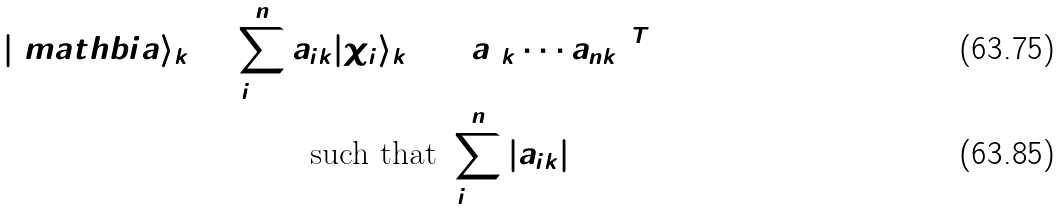<formula> <loc_0><loc_0><loc_500><loc_500>| \ m a t h b i { a } \rangle _ { k } = \sum _ { i = 1 } ^ { n } a _ { i k } | \chi _ { i } \rangle _ { k } = \left ( a _ { 1 k } \cdots a _ { n k } \right ) ^ { T } \\ \text {such that} \ \sum _ { i = 1 } ^ { n } | a _ { i k } | ^ { 2 } = 1</formula> 